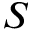Convert formula to latex. <formula><loc_0><loc_0><loc_500><loc_500>S</formula> 